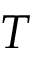Convert formula to latex. <formula><loc_0><loc_0><loc_500><loc_500>T</formula> 